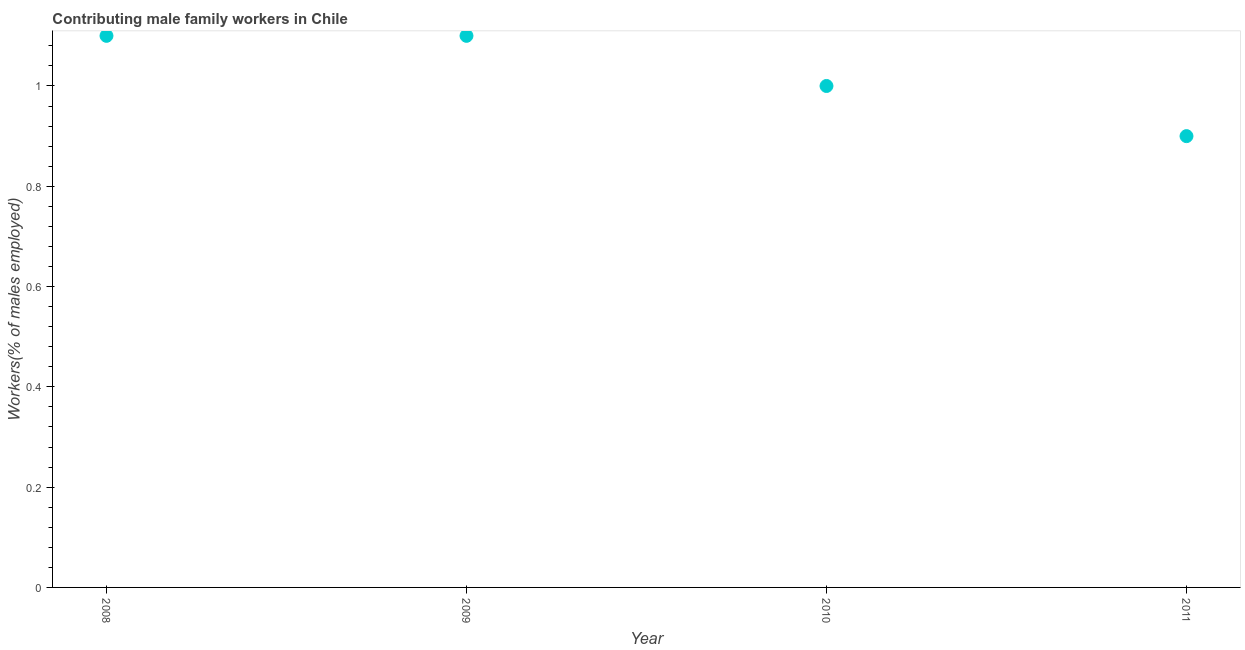What is the contributing male family workers in 2010?
Your answer should be very brief. 1. Across all years, what is the maximum contributing male family workers?
Ensure brevity in your answer.  1.1. Across all years, what is the minimum contributing male family workers?
Your response must be concise. 0.9. In which year was the contributing male family workers maximum?
Provide a succinct answer. 2008. What is the sum of the contributing male family workers?
Provide a succinct answer. 4.1. What is the difference between the contributing male family workers in 2008 and 2011?
Offer a very short reply. 0.2. What is the average contributing male family workers per year?
Make the answer very short. 1.03. What is the median contributing male family workers?
Ensure brevity in your answer.  1.05. Do a majority of the years between 2009 and 2010 (inclusive) have contributing male family workers greater than 0.8 %?
Offer a very short reply. Yes. What is the ratio of the contributing male family workers in 2009 to that in 2010?
Give a very brief answer. 1.1. What is the difference between the highest and the lowest contributing male family workers?
Your answer should be compact. 0.2. In how many years, is the contributing male family workers greater than the average contributing male family workers taken over all years?
Offer a terse response. 2. Does the contributing male family workers monotonically increase over the years?
Your response must be concise. No. How many years are there in the graph?
Provide a short and direct response. 4. What is the difference between two consecutive major ticks on the Y-axis?
Give a very brief answer. 0.2. Are the values on the major ticks of Y-axis written in scientific E-notation?
Provide a short and direct response. No. Does the graph contain any zero values?
Offer a terse response. No. Does the graph contain grids?
Keep it short and to the point. No. What is the title of the graph?
Your response must be concise. Contributing male family workers in Chile. What is the label or title of the X-axis?
Your response must be concise. Year. What is the label or title of the Y-axis?
Make the answer very short. Workers(% of males employed). What is the Workers(% of males employed) in 2008?
Provide a short and direct response. 1.1. What is the Workers(% of males employed) in 2009?
Make the answer very short. 1.1. What is the Workers(% of males employed) in 2011?
Offer a very short reply. 0.9. What is the difference between the Workers(% of males employed) in 2008 and 2009?
Provide a short and direct response. 0. What is the difference between the Workers(% of males employed) in 2008 and 2011?
Give a very brief answer. 0.2. What is the difference between the Workers(% of males employed) in 2009 and 2010?
Ensure brevity in your answer.  0.1. What is the difference between the Workers(% of males employed) in 2009 and 2011?
Your response must be concise. 0.2. What is the ratio of the Workers(% of males employed) in 2008 to that in 2010?
Give a very brief answer. 1.1. What is the ratio of the Workers(% of males employed) in 2008 to that in 2011?
Give a very brief answer. 1.22. What is the ratio of the Workers(% of males employed) in 2009 to that in 2011?
Give a very brief answer. 1.22. What is the ratio of the Workers(% of males employed) in 2010 to that in 2011?
Ensure brevity in your answer.  1.11. 